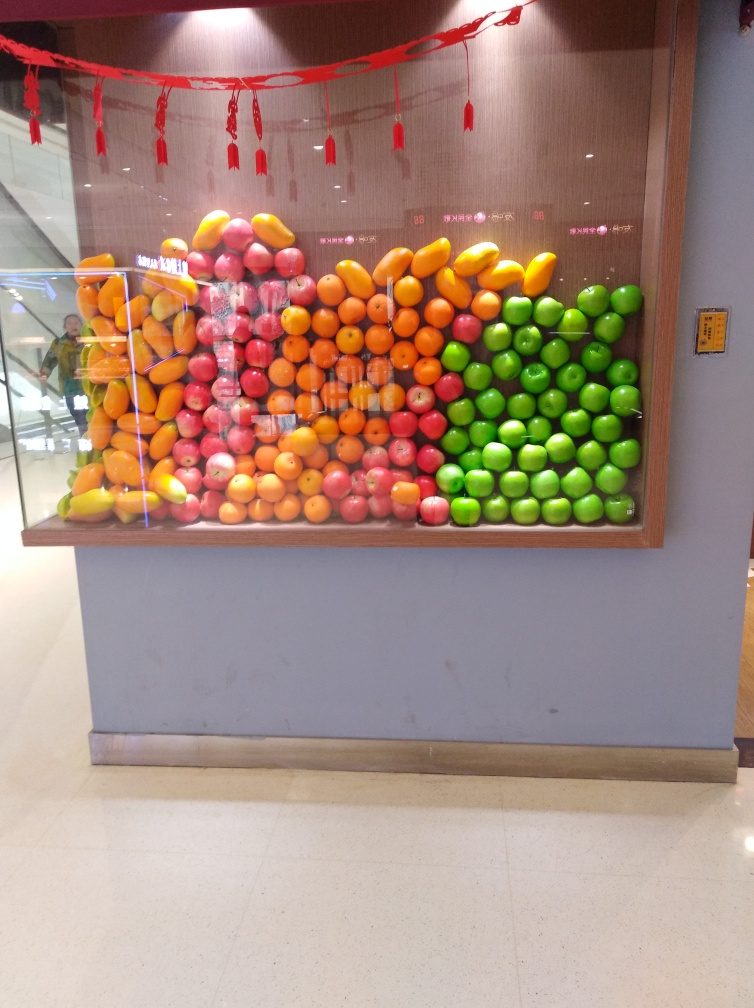What kind of arrangement is shown in the image? The image displays a vibrant, geometric arrangement of fruits, systematically organized by color to create a gradient transition from green to orange tones. It's a visually striking pattern that could symbolize abundance or be part of a decorative installation. Does this arrangement serve a purpose? Though the precise intention isn't clear without more context, such arrangements can serve aesthetic purposes, such as in celebration of a festival or event, or they might be part of a marketing display to attract attention to a produce area within a store or market. 